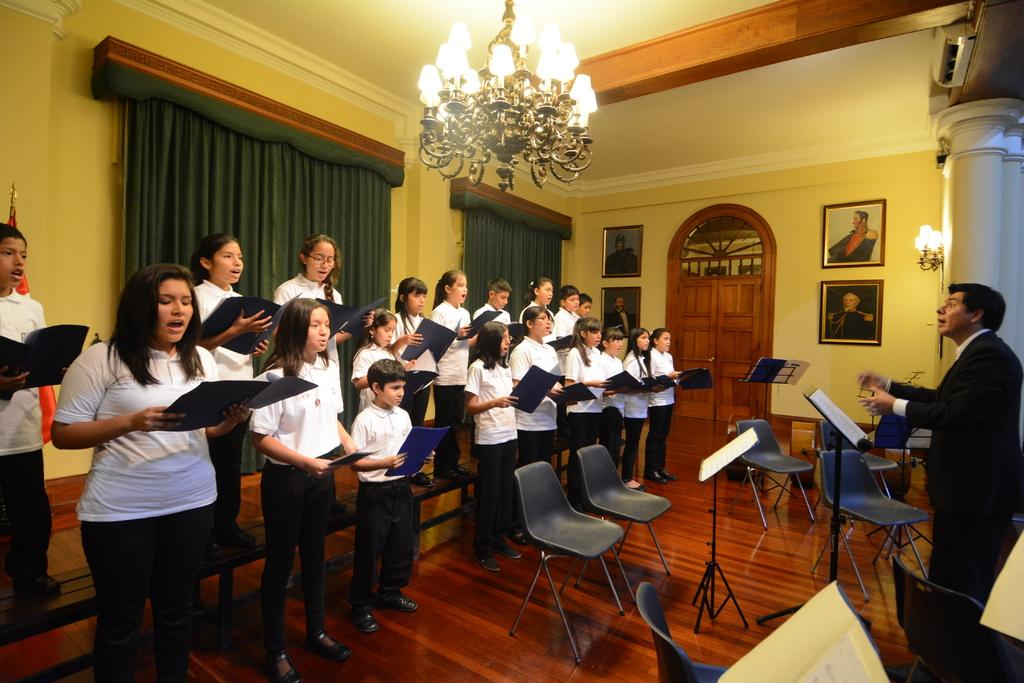What color is the wall that is visible in the image? There is a yellow color wall in the image. What type of window treatment is present in the image? There is a curtain in the image. What architectural feature can be seen in the image? There is a door in the image. What are the people in the image holding? The people standing in the image are holding books in their hands. What type of furniture is present in the image? There are chairs in the image. Where are the toys located in the image? There are no toys present in the image. What type of veil is draped over the curtain in the image? There is no veil present in the image; only a curtain is visible. 